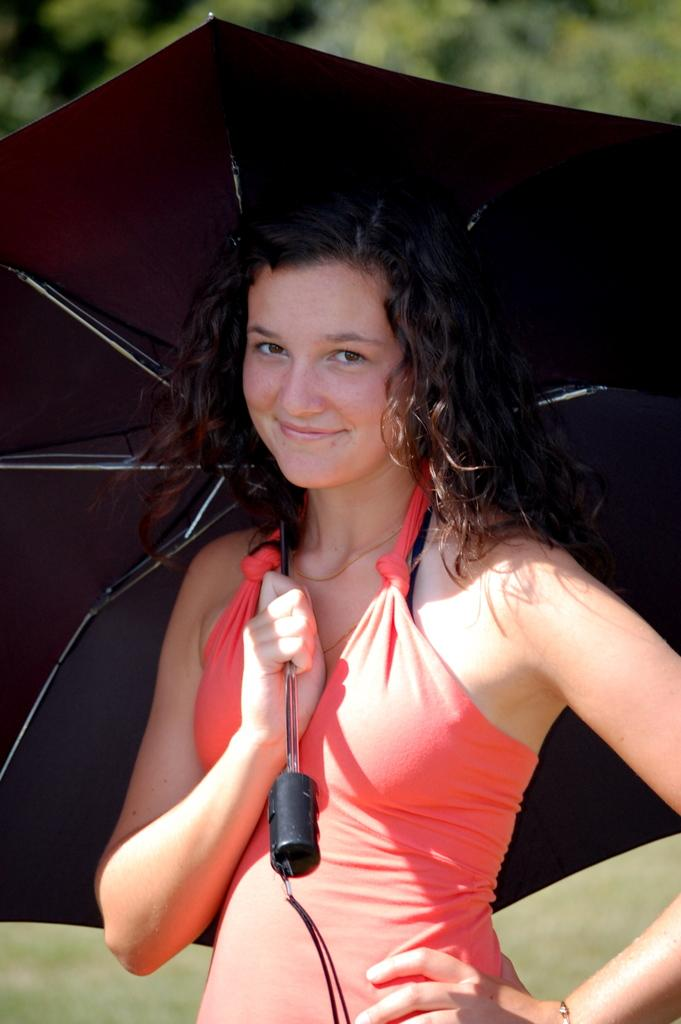Who is the main subject in the image? There is a girl in the image. What is the girl holding in the image? The girl is holding an umbrella. Where is the girl located in the image? The girl is in the foreground area. What can be seen in the background of the image? There is greenery in the background of the image. What type of rose can be seen on the table in the image? There is no rose or table present in the image; it features a girl holding an umbrella. What kind of noise can be heard coming from the girl in the image? There is no indication of any noise in the image, as it is a still photograph. 